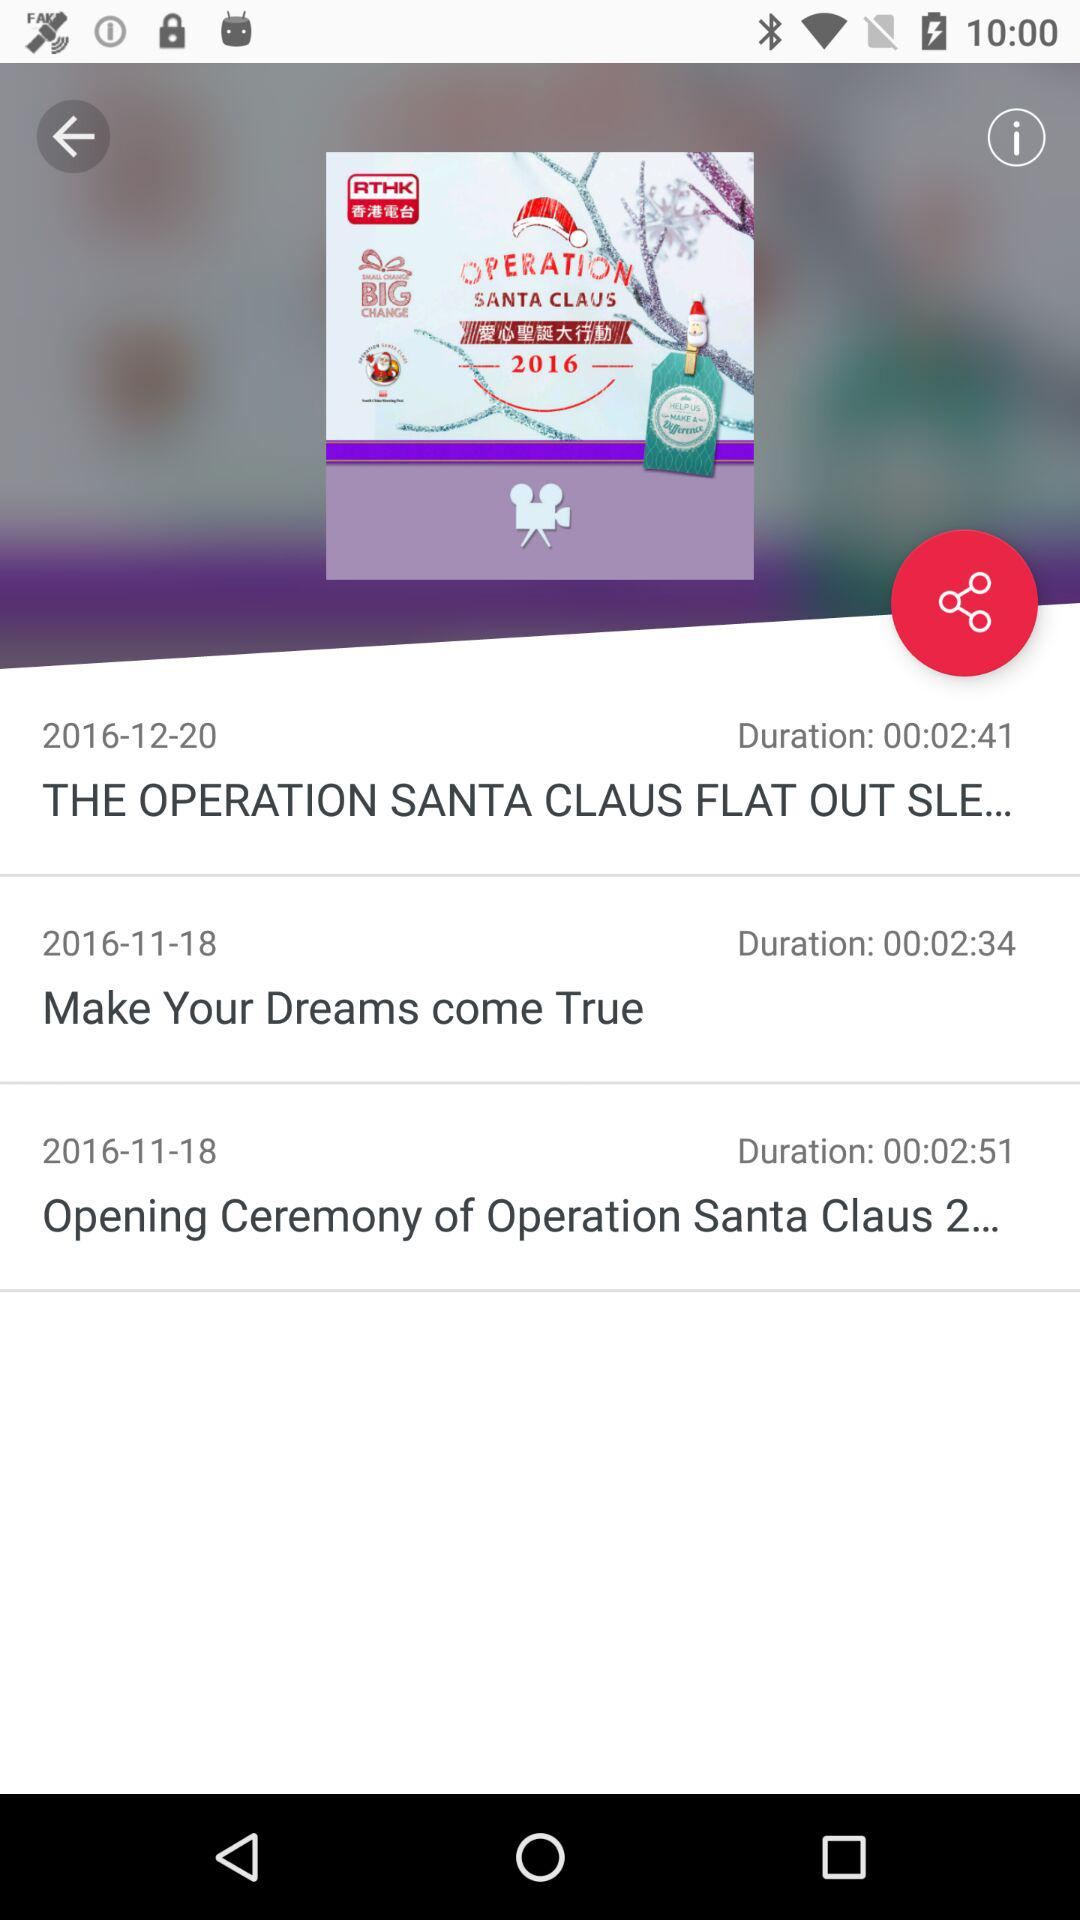Which video is longer, Make Your Dreams come True or Opening Ceremony of Operation Santa Claus 2?
Answer the question using a single word or phrase. Opening Ceremony of Operation Santa Claus 2 